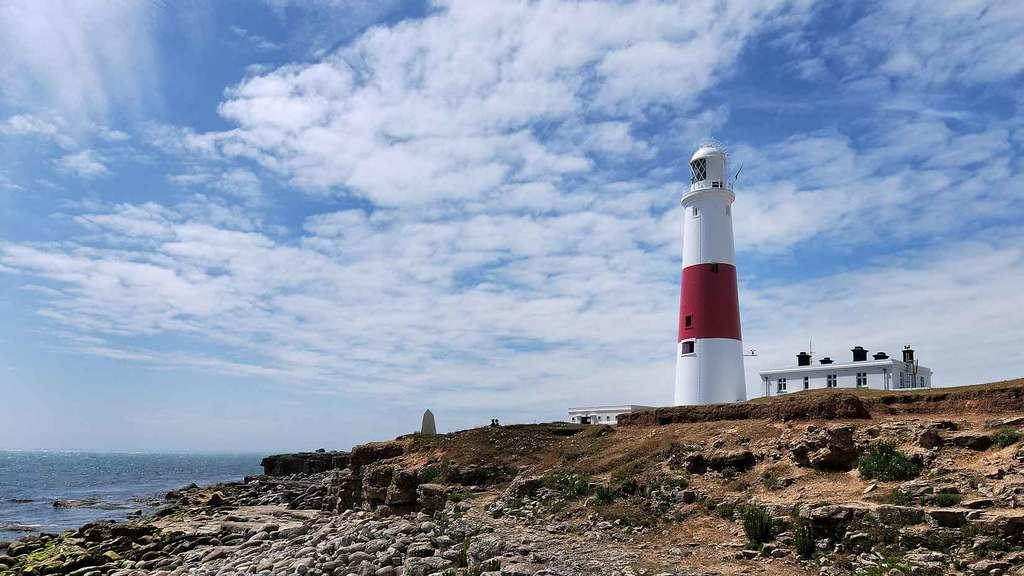What structure is located on the right side of the image? There is a lighthouse on the right side of the image. What other structure is on the right side of the image? There is a building on the right side of the image. What can be seen on the left side of the image? There is water on the left side of the image. What type of terrain is visible at the bottom of the image? Rocks are visible at the bottom of the image. What is visible in the background of the image? The sky is visible in the background of the image. What type of parcel is being delivered to the lighthouse in the image? There is no parcel being delivered to the lighthouse in the image. What type of celery is growing near the water in the image? There is no celery present in the image. 